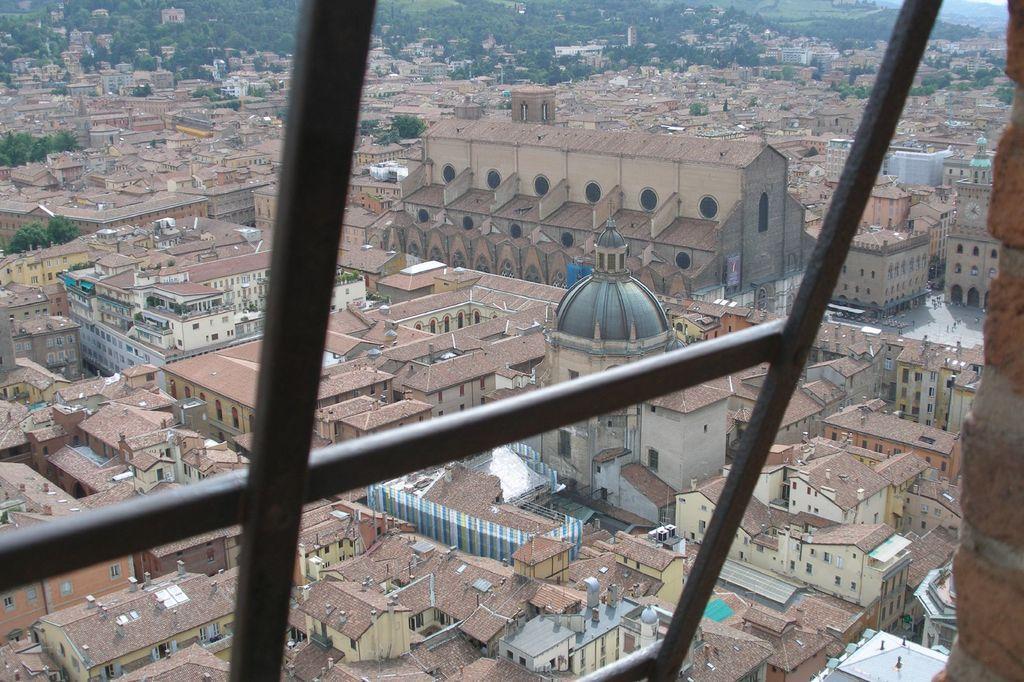Could you give a brief overview of what you see in this image? On the right side of this image there is a wall. On the left side I can see a metal object. In the background there are many buildings. At the top of the image there are many trees. 